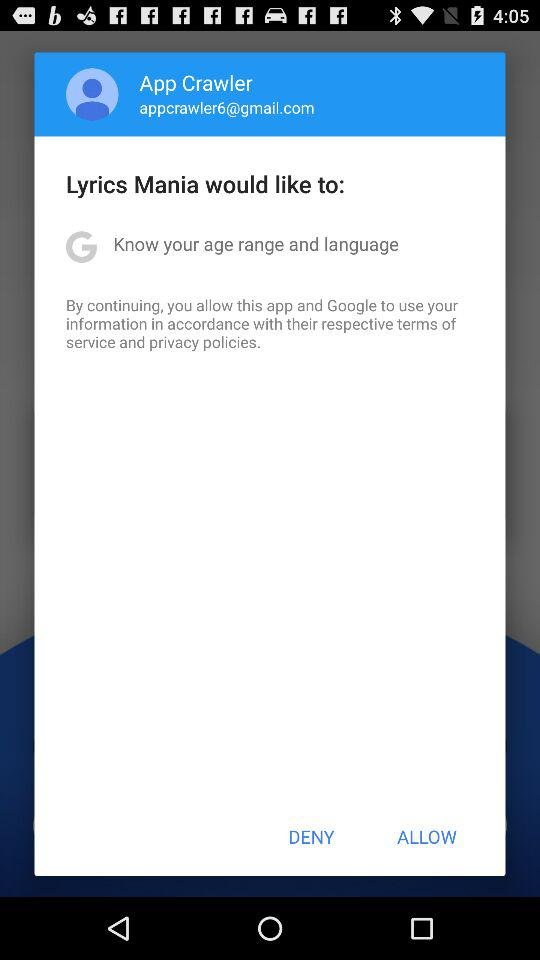What is the username? The user name is "App Crawler". 